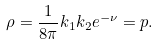<formula> <loc_0><loc_0><loc_500><loc_500>\rho = \frac { 1 } { 8 \pi } k _ { 1 } k _ { 2 } e ^ { - \nu } = p .</formula> 